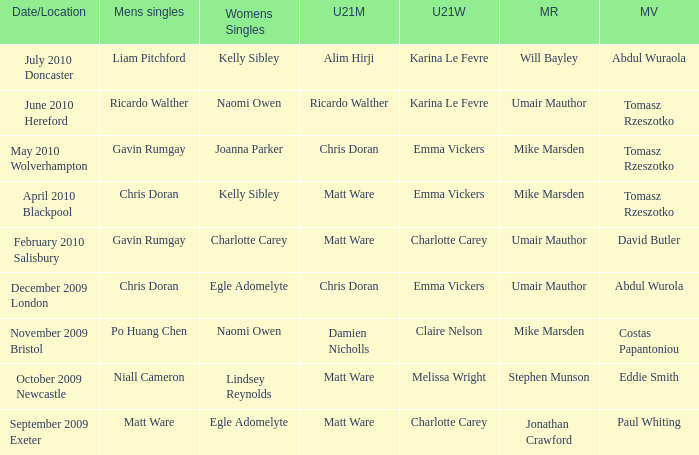Parse the full table. {'header': ['Date/Location', 'Mens singles', 'Womens Singles', 'U21M', 'U21W', 'MR', 'MV'], 'rows': [['July 2010 Doncaster', 'Liam Pitchford', 'Kelly Sibley', 'Alim Hirji', 'Karina Le Fevre', 'Will Bayley', 'Abdul Wuraola'], ['June 2010 Hereford', 'Ricardo Walther', 'Naomi Owen', 'Ricardo Walther', 'Karina Le Fevre', 'Umair Mauthor', 'Tomasz Rzeszotko'], ['May 2010 Wolverhampton', 'Gavin Rumgay', 'Joanna Parker', 'Chris Doran', 'Emma Vickers', 'Mike Marsden', 'Tomasz Rzeszotko'], ['April 2010 Blackpool', 'Chris Doran', 'Kelly Sibley', 'Matt Ware', 'Emma Vickers', 'Mike Marsden', 'Tomasz Rzeszotko'], ['February 2010 Salisbury', 'Gavin Rumgay', 'Charlotte Carey', 'Matt Ware', 'Charlotte Carey', 'Umair Mauthor', 'David Butler'], ['December 2009 London', 'Chris Doran', 'Egle Adomelyte', 'Chris Doran', 'Emma Vickers', 'Umair Mauthor', 'Abdul Wurola'], ['November 2009 Bristol', 'Po Huang Chen', 'Naomi Owen', 'Damien Nicholls', 'Claire Nelson', 'Mike Marsden', 'Costas Papantoniou'], ['October 2009 Newcastle', 'Niall Cameron', 'Lindsey Reynolds', 'Matt Ware', 'Melissa Wright', 'Stephen Munson', 'Eddie Smith'], ['September 2009 Exeter', 'Matt Ware', 'Egle Adomelyte', 'Matt Ware', 'Charlotte Carey', 'Jonathan Crawford', 'Paul Whiting']]} When Naomi Owen won the Womens Singles and Ricardo Walther won the Mens Singles, who won the mixed veteran? Tomasz Rzeszotko. 